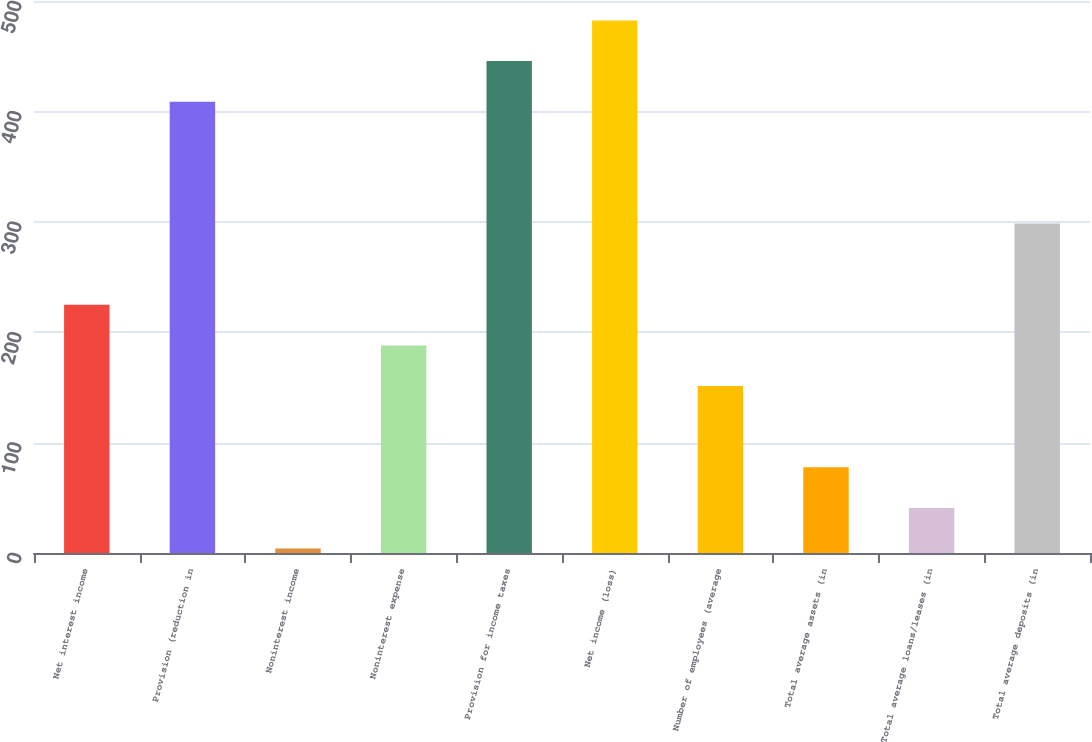<chart> <loc_0><loc_0><loc_500><loc_500><bar_chart><fcel>Net interest income<fcel>Provision (reduction in<fcel>Noninterest income<fcel>Noninterest expense<fcel>Provision for income taxes<fcel>Net income (loss)<fcel>Number of employees (average<fcel>Total average assets (in<fcel>Total average loans/leases (in<fcel>Total average deposits (in<nl><fcel>224.8<fcel>408.8<fcel>4<fcel>188<fcel>445.6<fcel>482.4<fcel>151.2<fcel>77.6<fcel>40.8<fcel>298.4<nl></chart> 